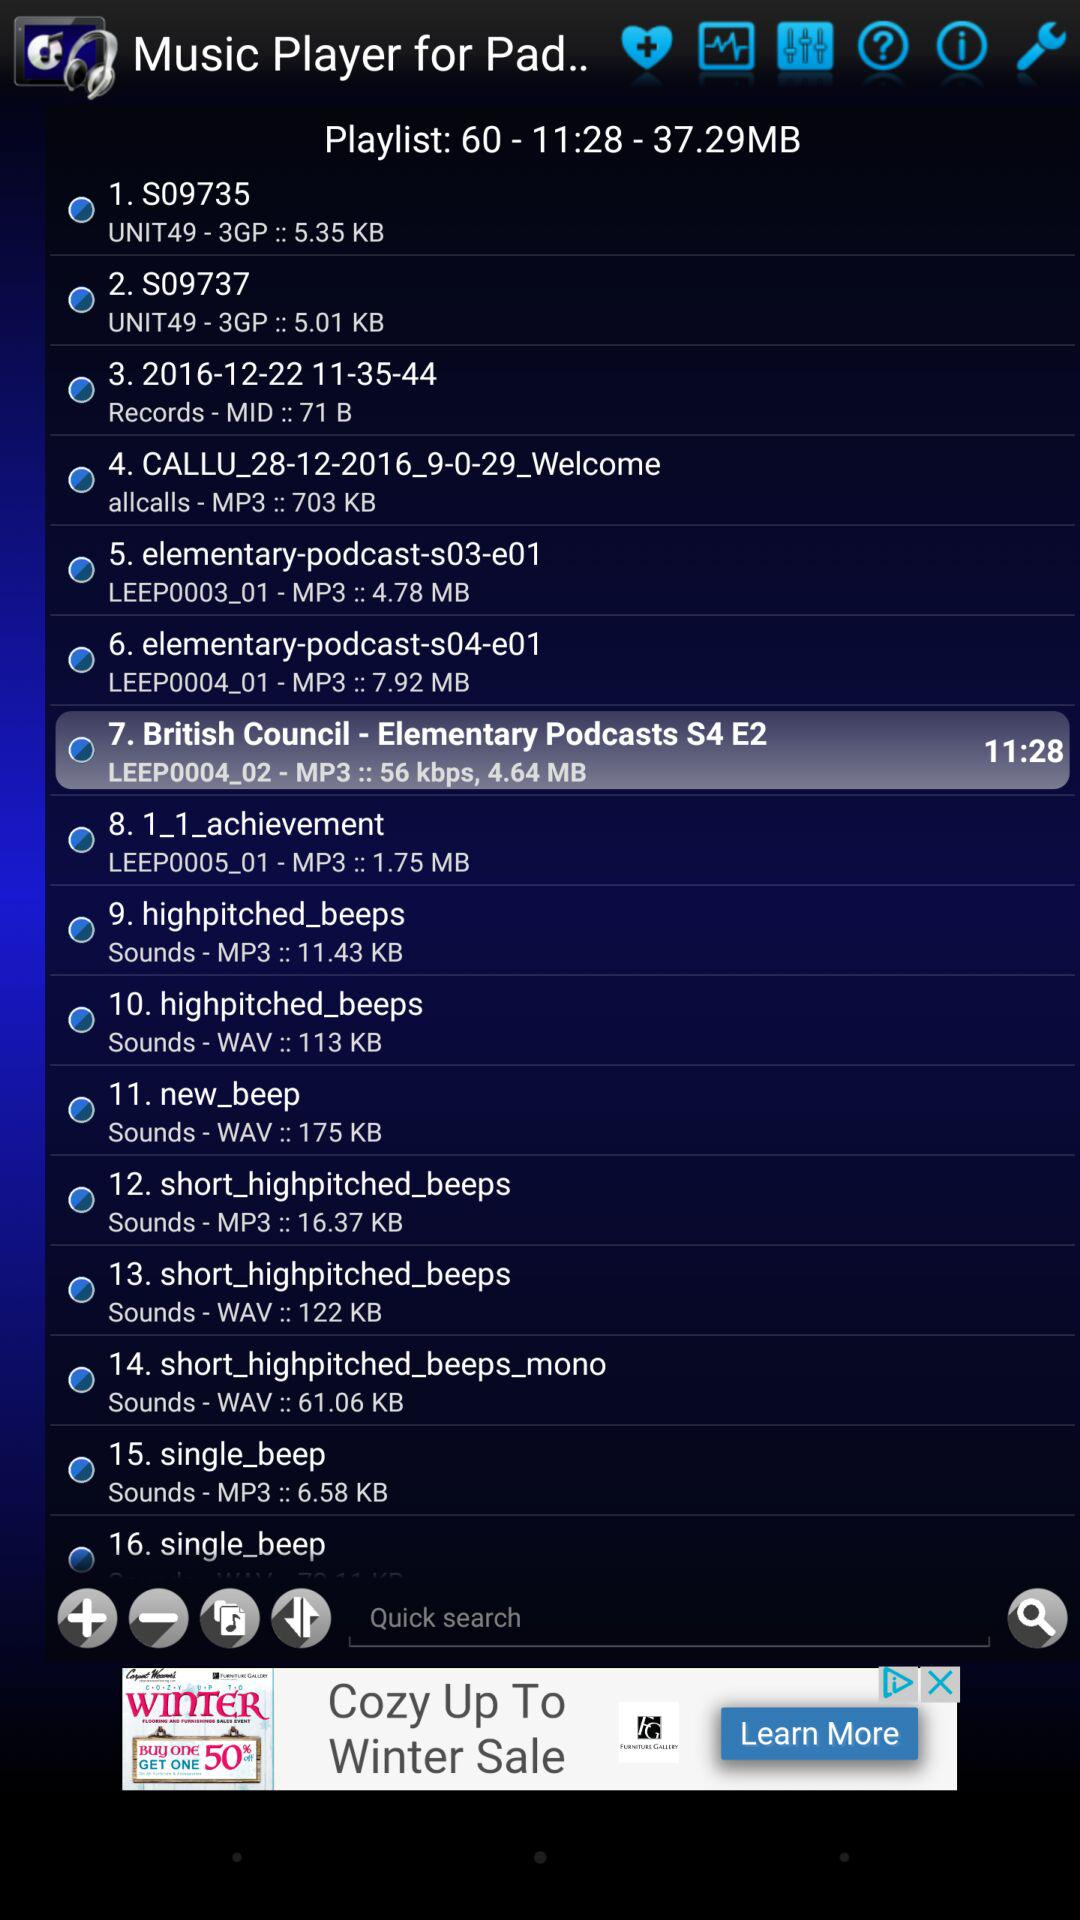What is the name of the seventh audio file in the playlist? The name of the seventh audio file is "British Council - Elementary Podcasts S4 E2". 